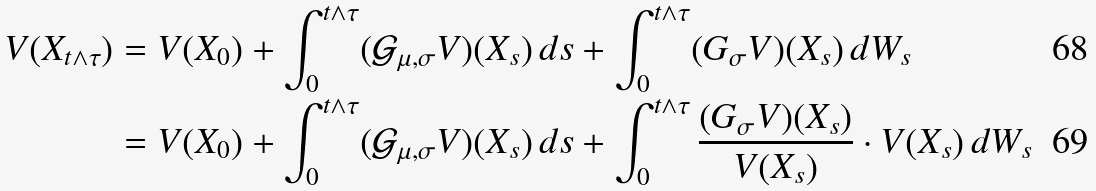<formula> <loc_0><loc_0><loc_500><loc_500>V ( X _ { t \wedge \tau } ) & = V ( X _ { 0 } ) + \int _ { 0 } ^ { t \wedge \tau } ( \mathcal { G } _ { \mu , \sigma } V ) ( X _ { s } ) \, d s + \int _ { 0 } ^ { t \wedge \tau } ( G _ { \sigma } V ) ( X _ { s } ) \, d W _ { s } \\ & = V ( X _ { 0 } ) + \int _ { 0 } ^ { t \wedge \tau } ( \mathcal { G } _ { \mu , \sigma } V ) ( X _ { s } ) \, d s + \int _ { 0 } ^ { t \wedge \tau } \frac { ( G _ { \sigma } V ) ( X _ { s } ) } { V ( X _ { s } ) } \cdot V ( X _ { s } ) \, d W _ { s }</formula> 